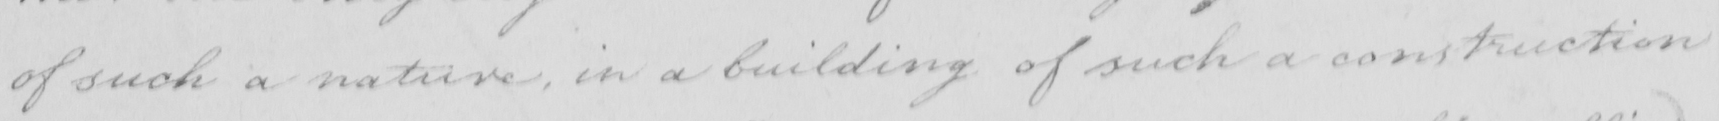Can you tell me what this handwritten text says? of such a nature in a building of such construction 